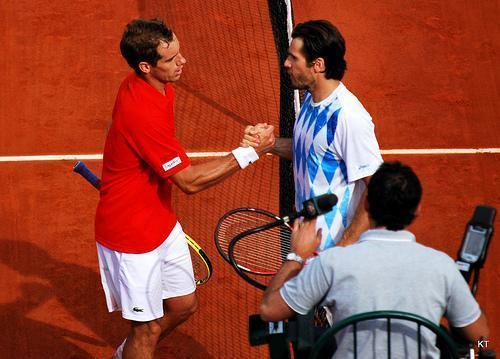How many people are shown?
Give a very brief answer. 3. 